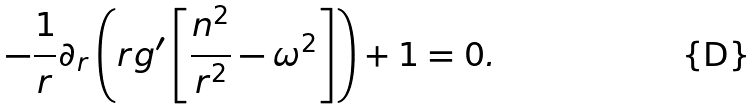Convert formula to latex. <formula><loc_0><loc_0><loc_500><loc_500>- \frac { 1 } { r } \partial _ { r } \left ( r g ^ { \prime } \left [ \frac { n ^ { 2 } } { r ^ { 2 } } - \omega ^ { 2 } \right ] \right ) + 1 = 0 .</formula> 